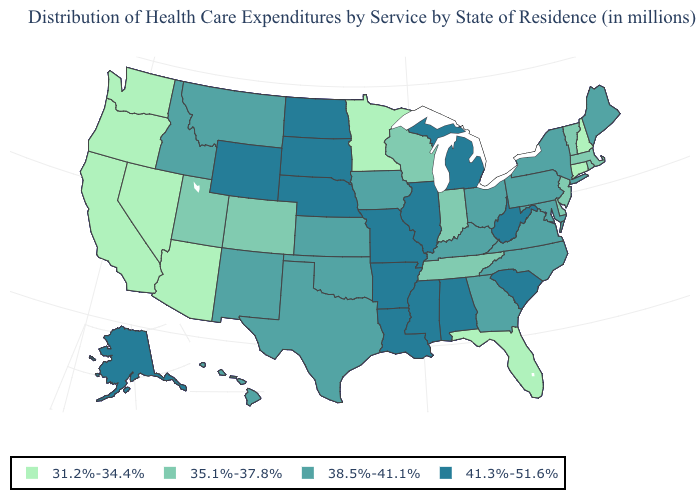How many symbols are there in the legend?
Keep it brief. 4. What is the value of Connecticut?
Give a very brief answer. 31.2%-34.4%. What is the lowest value in the USA?
Be succinct. 31.2%-34.4%. What is the value of Rhode Island?
Write a very short answer. 35.1%-37.8%. Does North Carolina have the same value as New York?
Keep it brief. Yes. Name the states that have a value in the range 31.2%-34.4%?
Quick response, please. Arizona, California, Connecticut, Florida, Minnesota, Nevada, New Hampshire, Oregon, Washington. What is the lowest value in the USA?
Short answer required. 31.2%-34.4%. What is the value of Illinois?
Short answer required. 41.3%-51.6%. What is the value of Texas?
Quick response, please. 38.5%-41.1%. What is the value of Illinois?
Quick response, please. 41.3%-51.6%. Name the states that have a value in the range 41.3%-51.6%?
Keep it brief. Alabama, Alaska, Arkansas, Illinois, Louisiana, Michigan, Mississippi, Missouri, Nebraska, North Dakota, South Carolina, South Dakota, West Virginia, Wyoming. What is the value of Wisconsin?
Be succinct. 35.1%-37.8%. What is the value of Michigan?
Concise answer only. 41.3%-51.6%. Does the first symbol in the legend represent the smallest category?
Write a very short answer. Yes. What is the value of Maine?
Concise answer only. 38.5%-41.1%. 